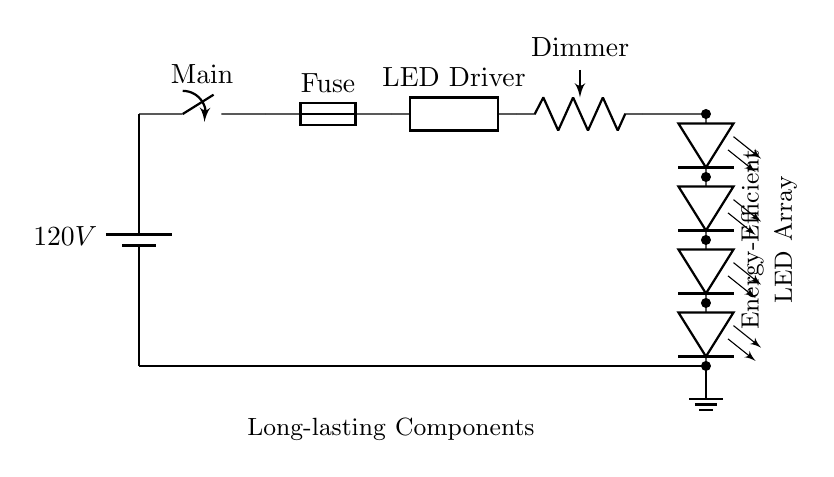What is the voltage of the battery? The circuit shows a battery labeled as 120V, which indicates the voltage supplied to the circuit components.
Answer: 120V What is the function of the potentiometer in this circuit? The potentiometer is labeled as a dimmer, which means its purpose is to vary the brightness of the LED array by adjusting the current flowing through it.
Answer: Dimmer How many LEDs are there in the LED array? The circuit diagram shows a series of four LEDs (represented with leDo symbols), which visually confirms the number of LEDs present in the array.
Answer: Four What is the component that protects the circuit from overload? The fuse is labeled in the diagram, and it's specifically designed to protect the circuit from excessive current by breaking the circuit if the current exceeds a certain limit.
Answer: Fuse What is the significance of the LED driver in this circuit? The LED driver is positioned between the power source (battery) and the dimmer. Its role is to convert the input voltage and current to levels suitable for the LEDs, ensuring efficient operation while providing necessary power regulation.
Answer: LED Driver How does the dimmer affect the LED array? The dimmer, being a potentiometer, controls the resistance in the circuit, which in turn regulates the current flowing to the LED array, allowing for changes in brightness according to user preference.
Answer: Regulates brightness 